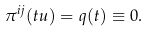Convert formula to latex. <formula><loc_0><loc_0><loc_500><loc_500>\pi ^ { i j } ( t u ) = q ( t ) \equiv 0 .</formula> 